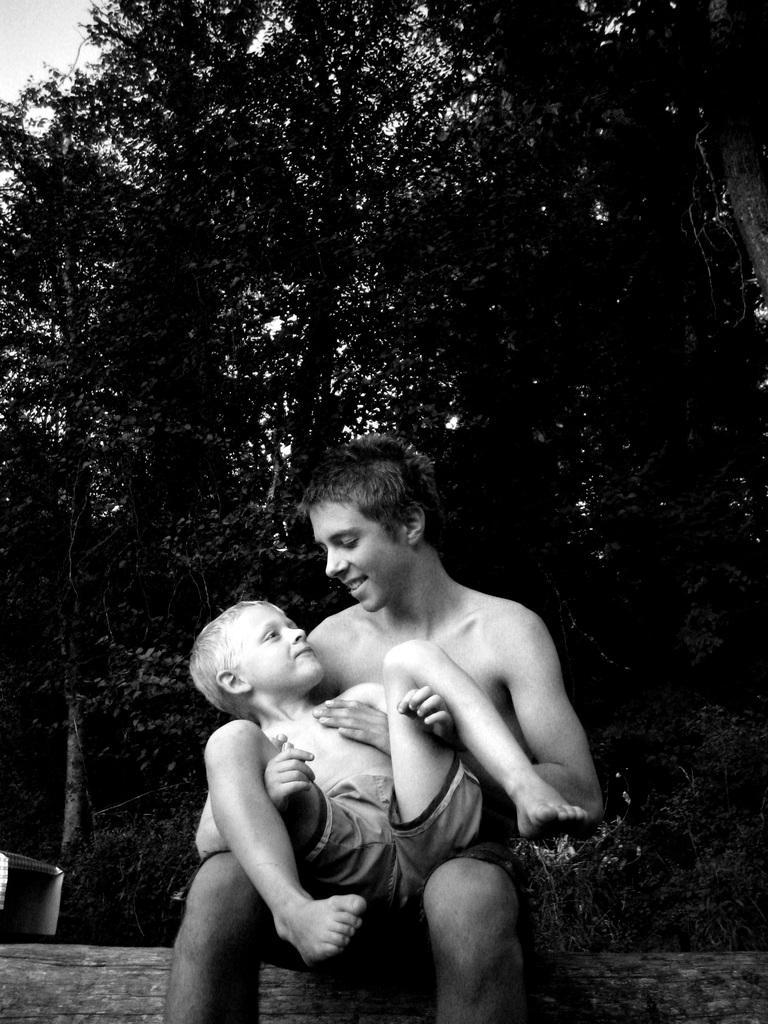Please provide a concise description of this image. In this picture we can see a man and a kid here, in the background there are trees, we can see the sky at the left top of the picture. 